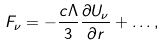Convert formula to latex. <formula><loc_0><loc_0><loc_500><loc_500>F _ { \nu } = - \frac { c \Lambda } { 3 } \frac { \partial U _ { \nu } } { \partial r } + \dots ,</formula> 